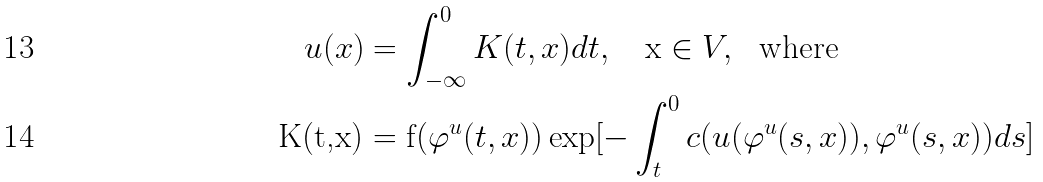Convert formula to latex. <formula><loc_0><loc_0><loc_500><loc_500>u ( x ) & = \int _ { - \infty } ^ { 0 } K ( t , x ) d t , \text { \ \ x} \in V , \text { \ where} \\ \text {K(t,x)} & = \text {f(} \varphi ^ { u } ( t , x ) ) \exp [ - \int _ { t } ^ { 0 } c ( u ( \varphi ^ { u } ( s , x ) ) , \varphi ^ { u } ( s , x ) ) d s ]</formula> 